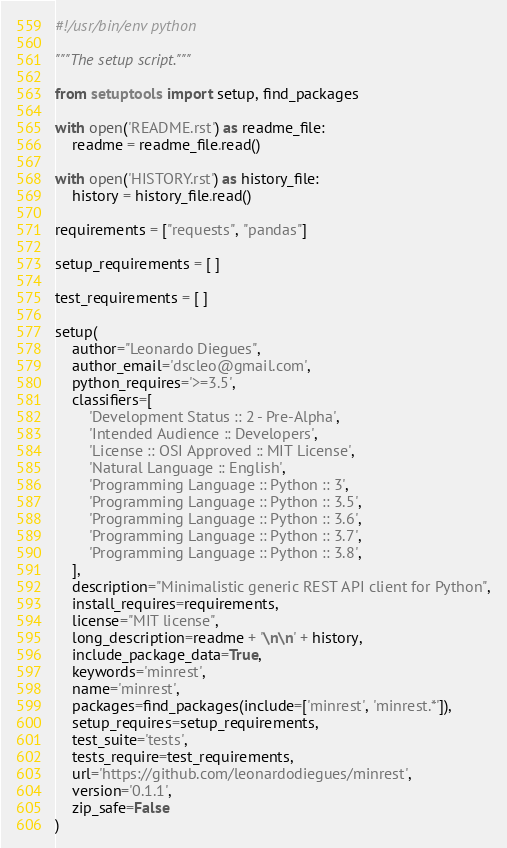<code> <loc_0><loc_0><loc_500><loc_500><_Python_>#!/usr/bin/env python

"""The setup script."""

from setuptools import setup, find_packages

with open('README.rst') as readme_file:
    readme = readme_file.read()

with open('HISTORY.rst') as history_file:
    history = history_file.read()

requirements = ["requests", "pandas"]

setup_requirements = [ ]

test_requirements = [ ]

setup(
    author="Leonardo Diegues",
    author_email='dscleo@gmail.com',
    python_requires='>=3.5',
    classifiers=[
        'Development Status :: 2 - Pre-Alpha',
        'Intended Audience :: Developers',
        'License :: OSI Approved :: MIT License',
        'Natural Language :: English',
        'Programming Language :: Python :: 3',
        'Programming Language :: Python :: 3.5',
        'Programming Language :: Python :: 3.6',
        'Programming Language :: Python :: 3.7',
        'Programming Language :: Python :: 3.8',
    ],
    description="Minimalistic generic REST API client for Python",
    install_requires=requirements,
    license="MIT license",
    long_description=readme + '\n\n' + history,
    include_package_data=True,
    keywords='minrest',
    name='minrest',
    packages=find_packages(include=['minrest', 'minrest.*']),
    setup_requires=setup_requirements,
    test_suite='tests',
    tests_require=test_requirements,
    url='https://github.com/leonardodiegues/minrest',
    version='0.1.1',
    zip_safe=False
)
</code> 